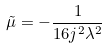Convert formula to latex. <formula><loc_0><loc_0><loc_500><loc_500>\tilde { \mu } = - \frac { 1 } { 1 6 j ^ { 2 } \lambda ^ { 2 } }</formula> 